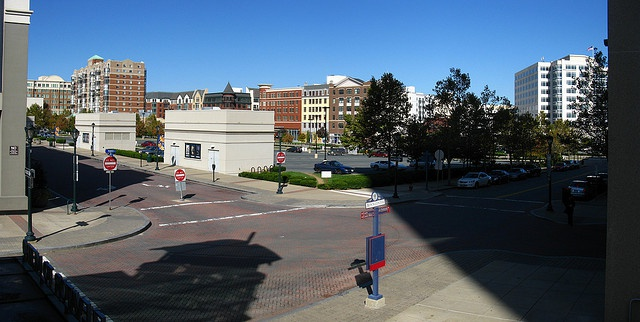Describe the objects in this image and their specific colors. I can see car in darkblue, black, navy, and blue tones, car in darkblue, black, navy, gray, and blue tones, car in darkblue, black, navy, blue, and gray tones, car in darkblue, black, navy, and blue tones, and car in darkblue, black, gray, and darkgray tones in this image. 